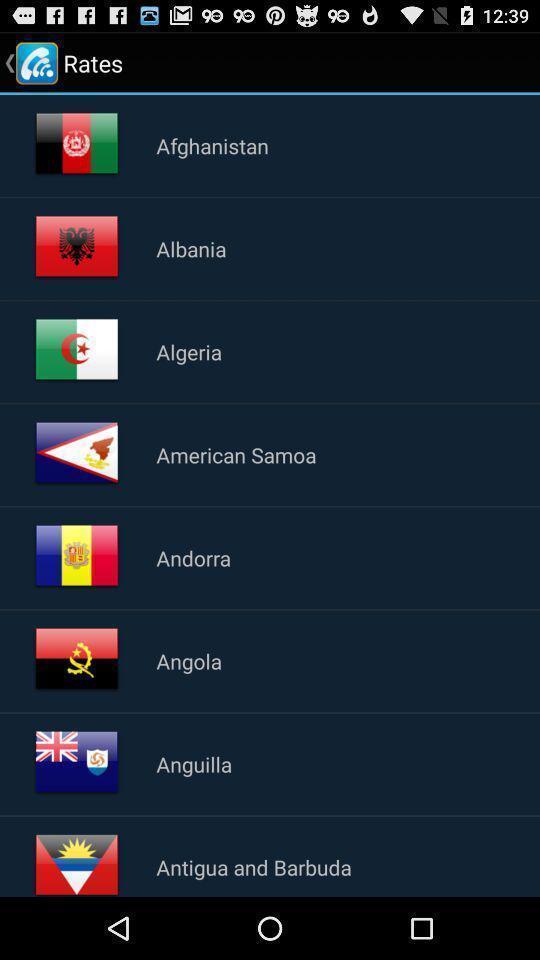Tell me about the visual elements in this screen capture. Screen displaying a list of country names. 